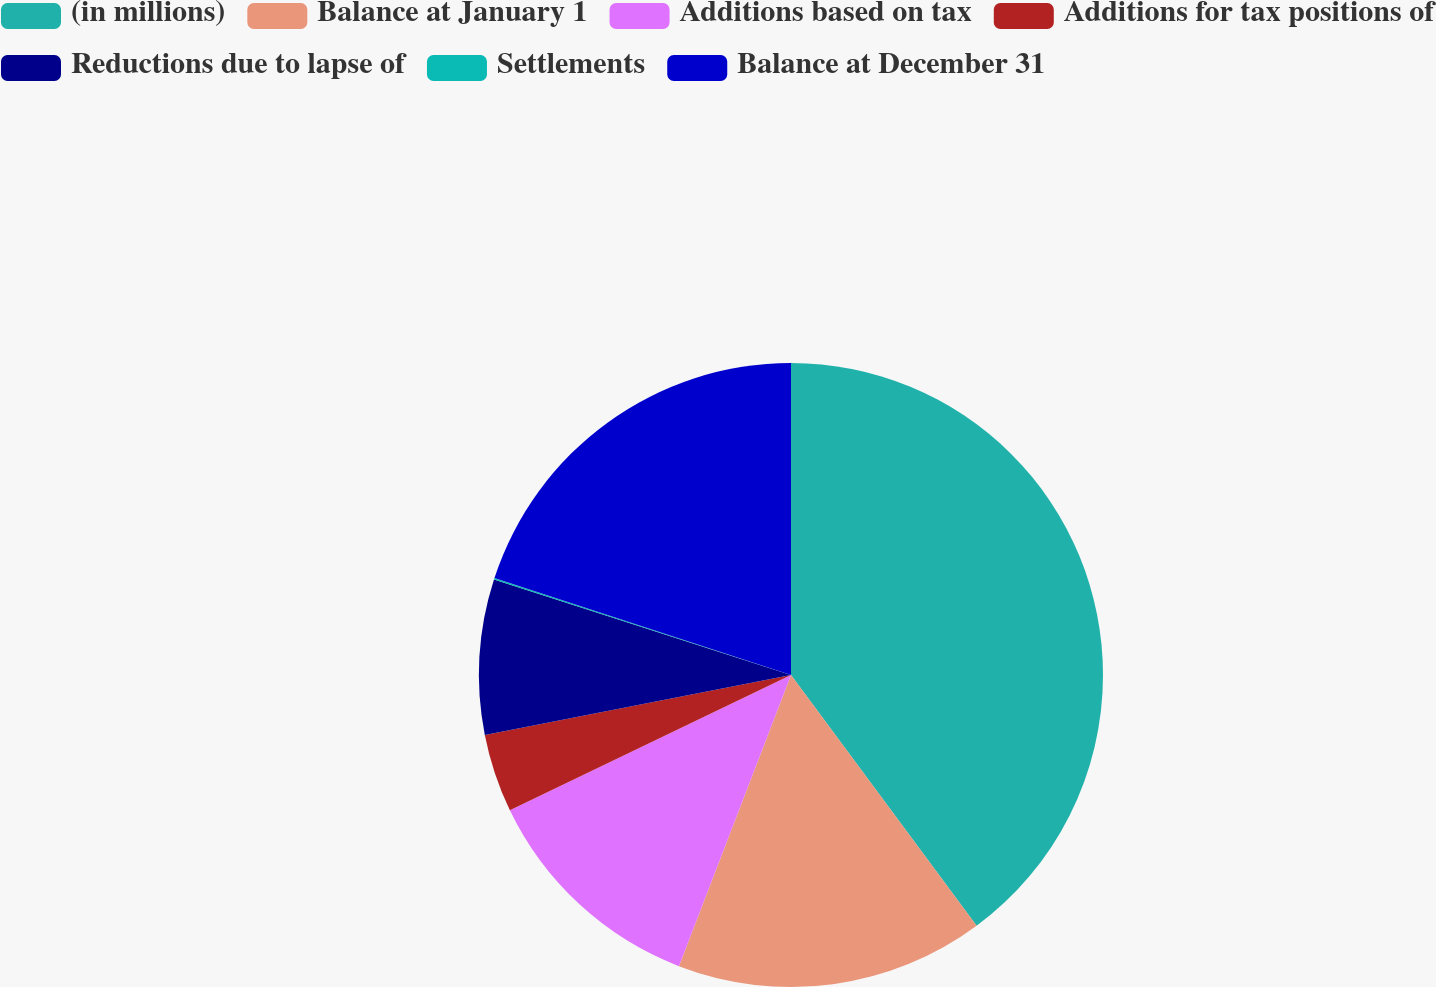Convert chart to OTSL. <chart><loc_0><loc_0><loc_500><loc_500><pie_chart><fcel>(in millions)<fcel>Balance at January 1<fcel>Additions based on tax<fcel>Additions for tax positions of<fcel>Reductions due to lapse of<fcel>Settlements<fcel>Balance at December 31<nl><fcel>39.86%<fcel>15.99%<fcel>12.01%<fcel>4.06%<fcel>8.03%<fcel>0.08%<fcel>19.97%<nl></chart> 